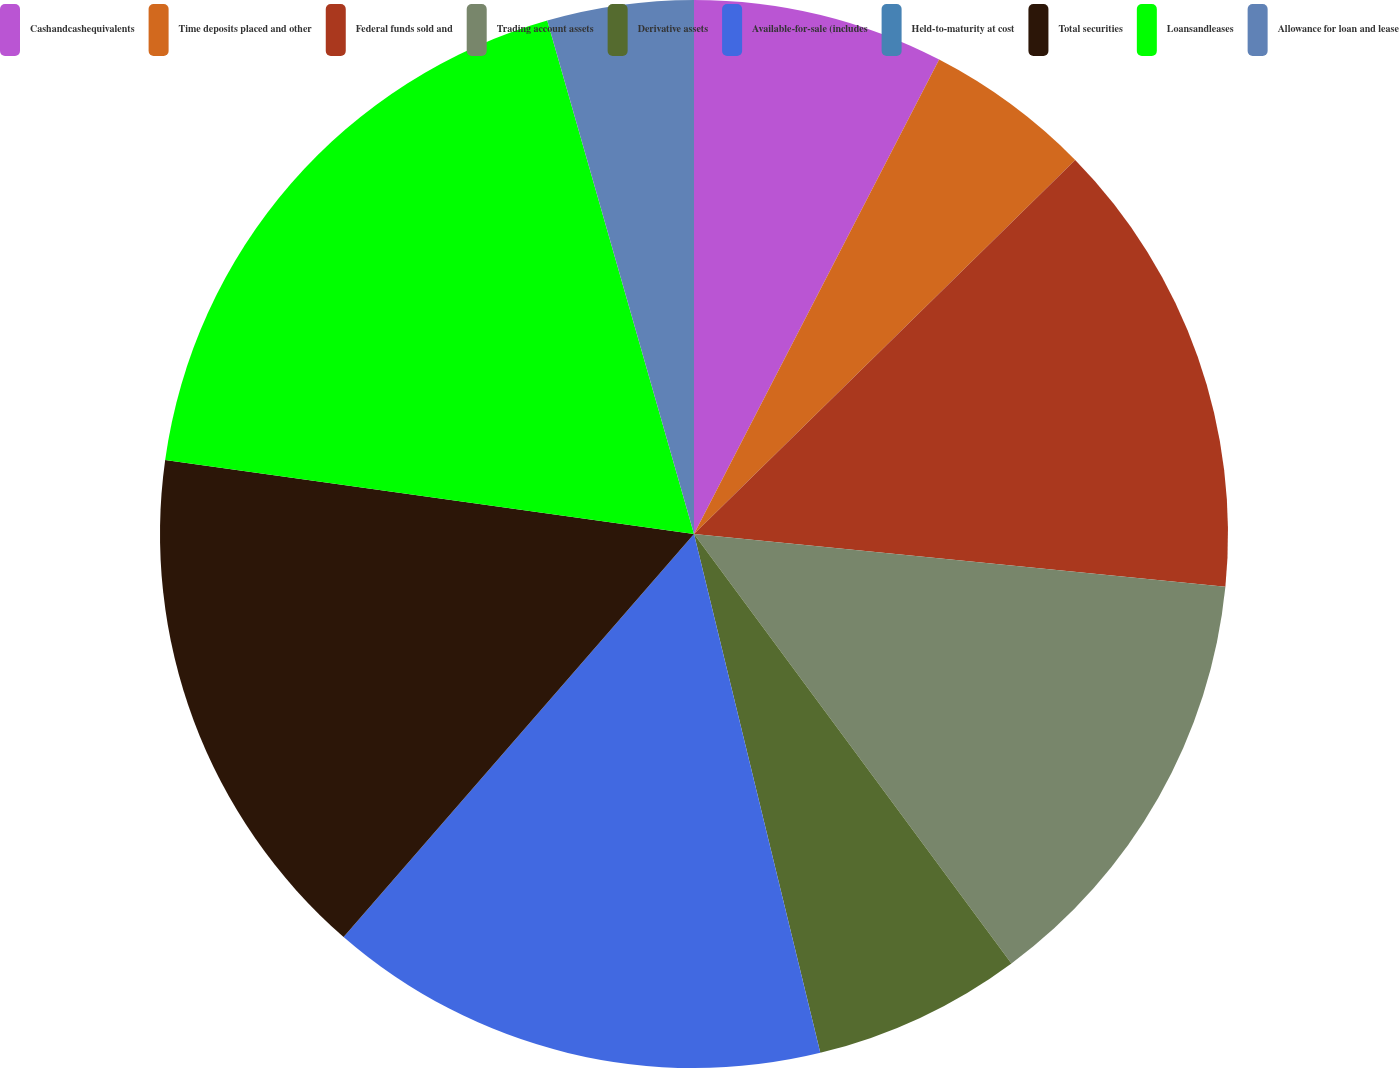<chart> <loc_0><loc_0><loc_500><loc_500><pie_chart><fcel>Cashandcashequivalents<fcel>Time deposits placed and other<fcel>Federal funds sold and<fcel>Trading account assets<fcel>Derivative assets<fcel>Available-for-sale (includes<fcel>Held-to-maturity at cost<fcel>Total securities<fcel>Loansandleases<fcel>Allowance for loan and lease<nl><fcel>7.59%<fcel>5.06%<fcel>13.92%<fcel>13.29%<fcel>6.33%<fcel>15.19%<fcel>0.0%<fcel>15.82%<fcel>18.35%<fcel>4.43%<nl></chart> 